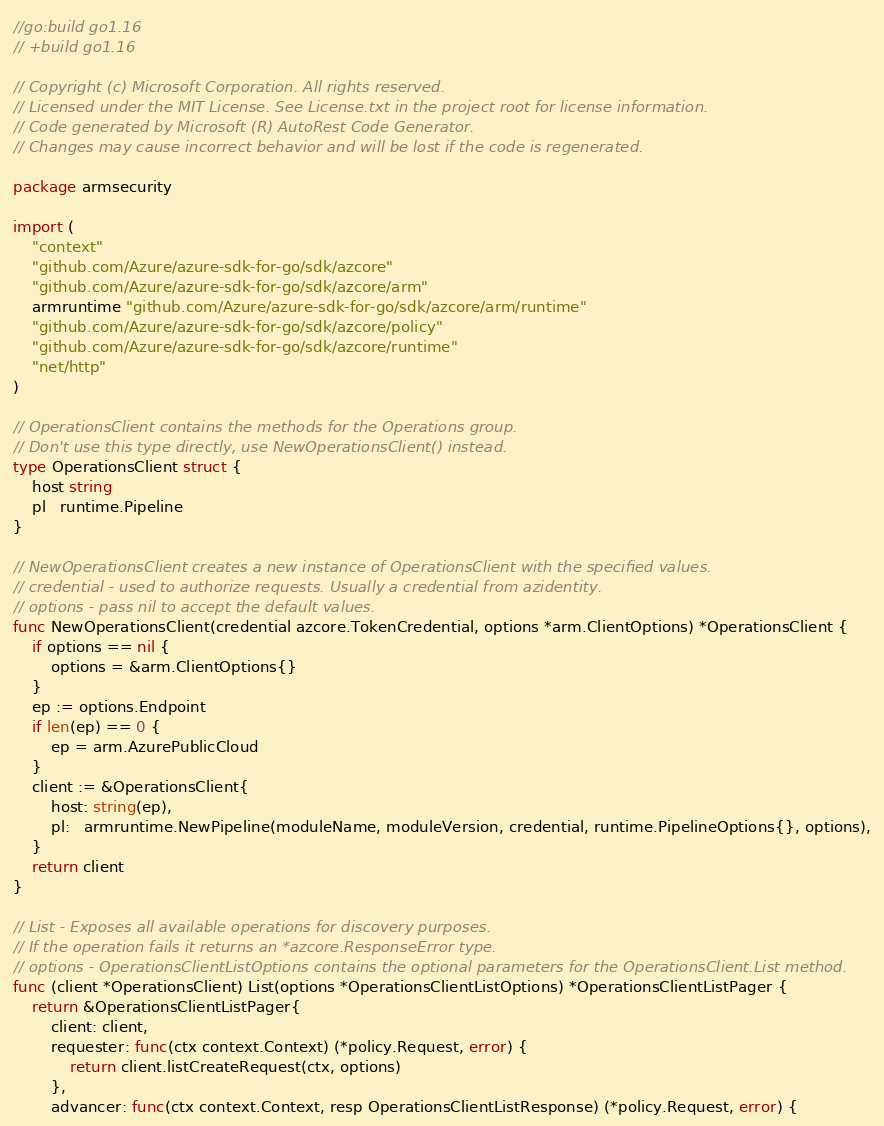Convert code to text. <code><loc_0><loc_0><loc_500><loc_500><_Go_>//go:build go1.16
// +build go1.16

// Copyright (c) Microsoft Corporation. All rights reserved.
// Licensed under the MIT License. See License.txt in the project root for license information.
// Code generated by Microsoft (R) AutoRest Code Generator.
// Changes may cause incorrect behavior and will be lost if the code is regenerated.

package armsecurity

import (
	"context"
	"github.com/Azure/azure-sdk-for-go/sdk/azcore"
	"github.com/Azure/azure-sdk-for-go/sdk/azcore/arm"
	armruntime "github.com/Azure/azure-sdk-for-go/sdk/azcore/arm/runtime"
	"github.com/Azure/azure-sdk-for-go/sdk/azcore/policy"
	"github.com/Azure/azure-sdk-for-go/sdk/azcore/runtime"
	"net/http"
)

// OperationsClient contains the methods for the Operations group.
// Don't use this type directly, use NewOperationsClient() instead.
type OperationsClient struct {
	host string
	pl   runtime.Pipeline
}

// NewOperationsClient creates a new instance of OperationsClient with the specified values.
// credential - used to authorize requests. Usually a credential from azidentity.
// options - pass nil to accept the default values.
func NewOperationsClient(credential azcore.TokenCredential, options *arm.ClientOptions) *OperationsClient {
	if options == nil {
		options = &arm.ClientOptions{}
	}
	ep := options.Endpoint
	if len(ep) == 0 {
		ep = arm.AzurePublicCloud
	}
	client := &OperationsClient{
		host: string(ep),
		pl:   armruntime.NewPipeline(moduleName, moduleVersion, credential, runtime.PipelineOptions{}, options),
	}
	return client
}

// List - Exposes all available operations for discovery purposes.
// If the operation fails it returns an *azcore.ResponseError type.
// options - OperationsClientListOptions contains the optional parameters for the OperationsClient.List method.
func (client *OperationsClient) List(options *OperationsClientListOptions) *OperationsClientListPager {
	return &OperationsClientListPager{
		client: client,
		requester: func(ctx context.Context) (*policy.Request, error) {
			return client.listCreateRequest(ctx, options)
		},
		advancer: func(ctx context.Context, resp OperationsClientListResponse) (*policy.Request, error) {</code> 